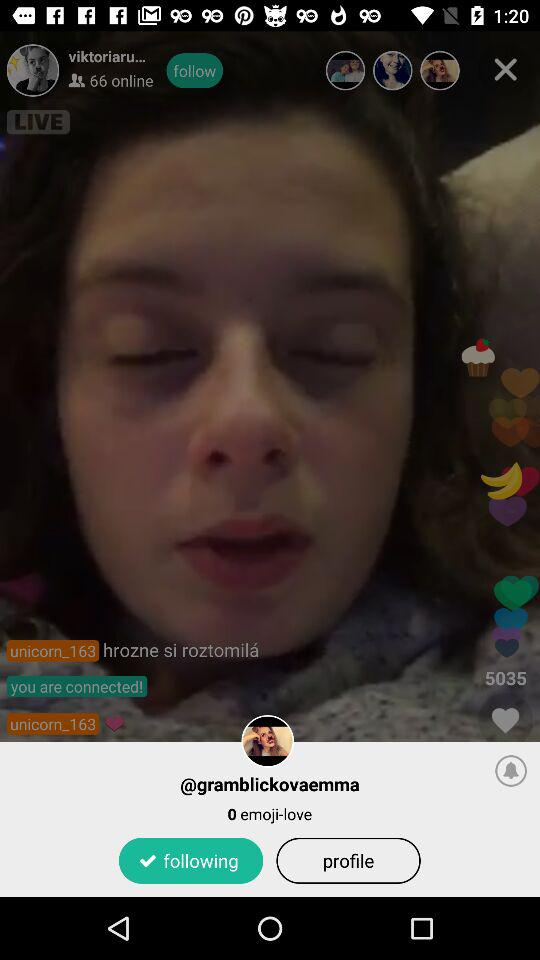What is the username? The username is "gramblickovaemma". 